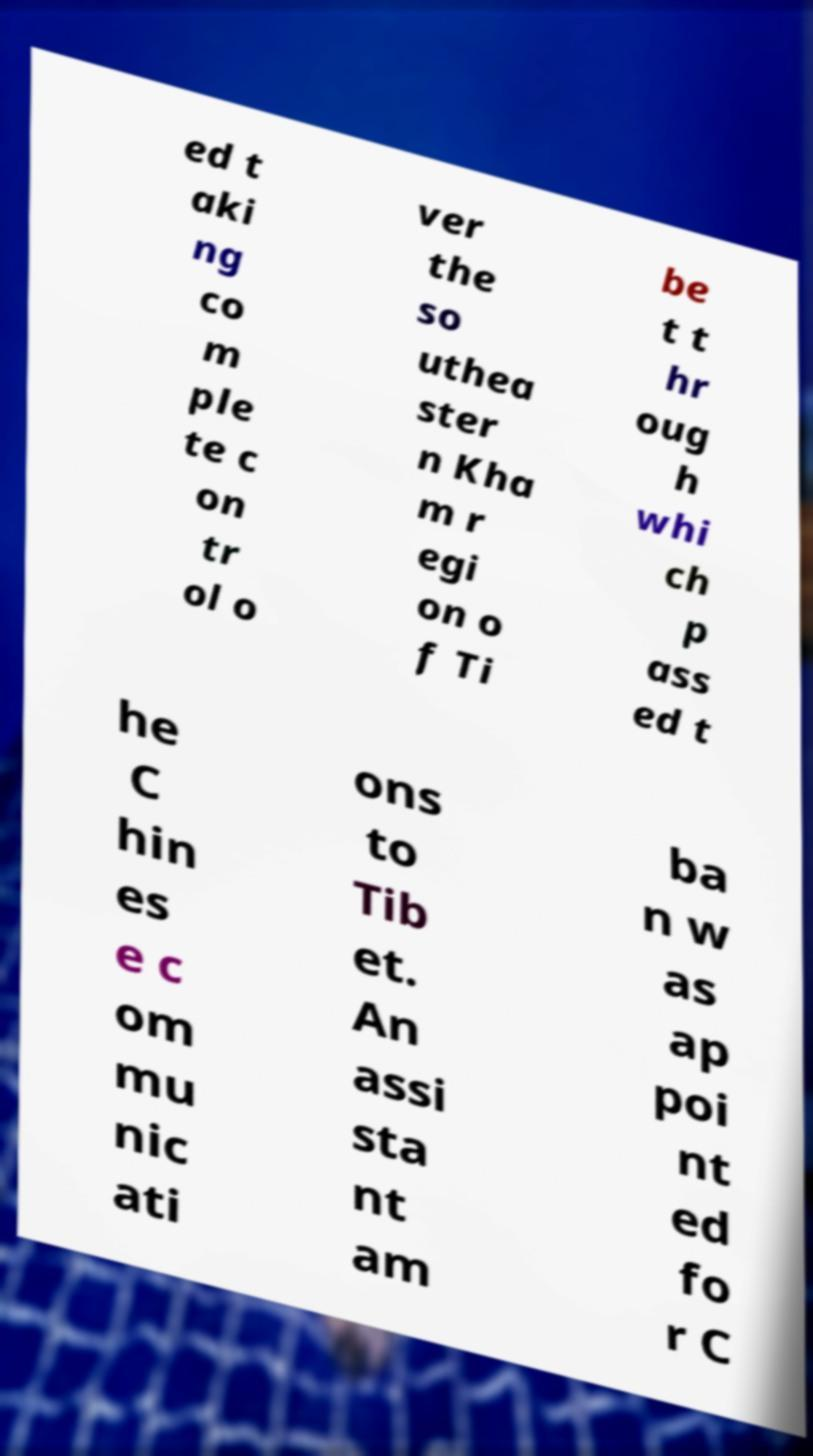What messages or text are displayed in this image? I need them in a readable, typed format. ed t aki ng co m ple te c on tr ol o ver the so uthea ster n Kha m r egi on o f Ti be t t hr oug h whi ch p ass ed t he C hin es e c om mu nic ati ons to Tib et. An assi sta nt am ba n w as ap poi nt ed fo r C 